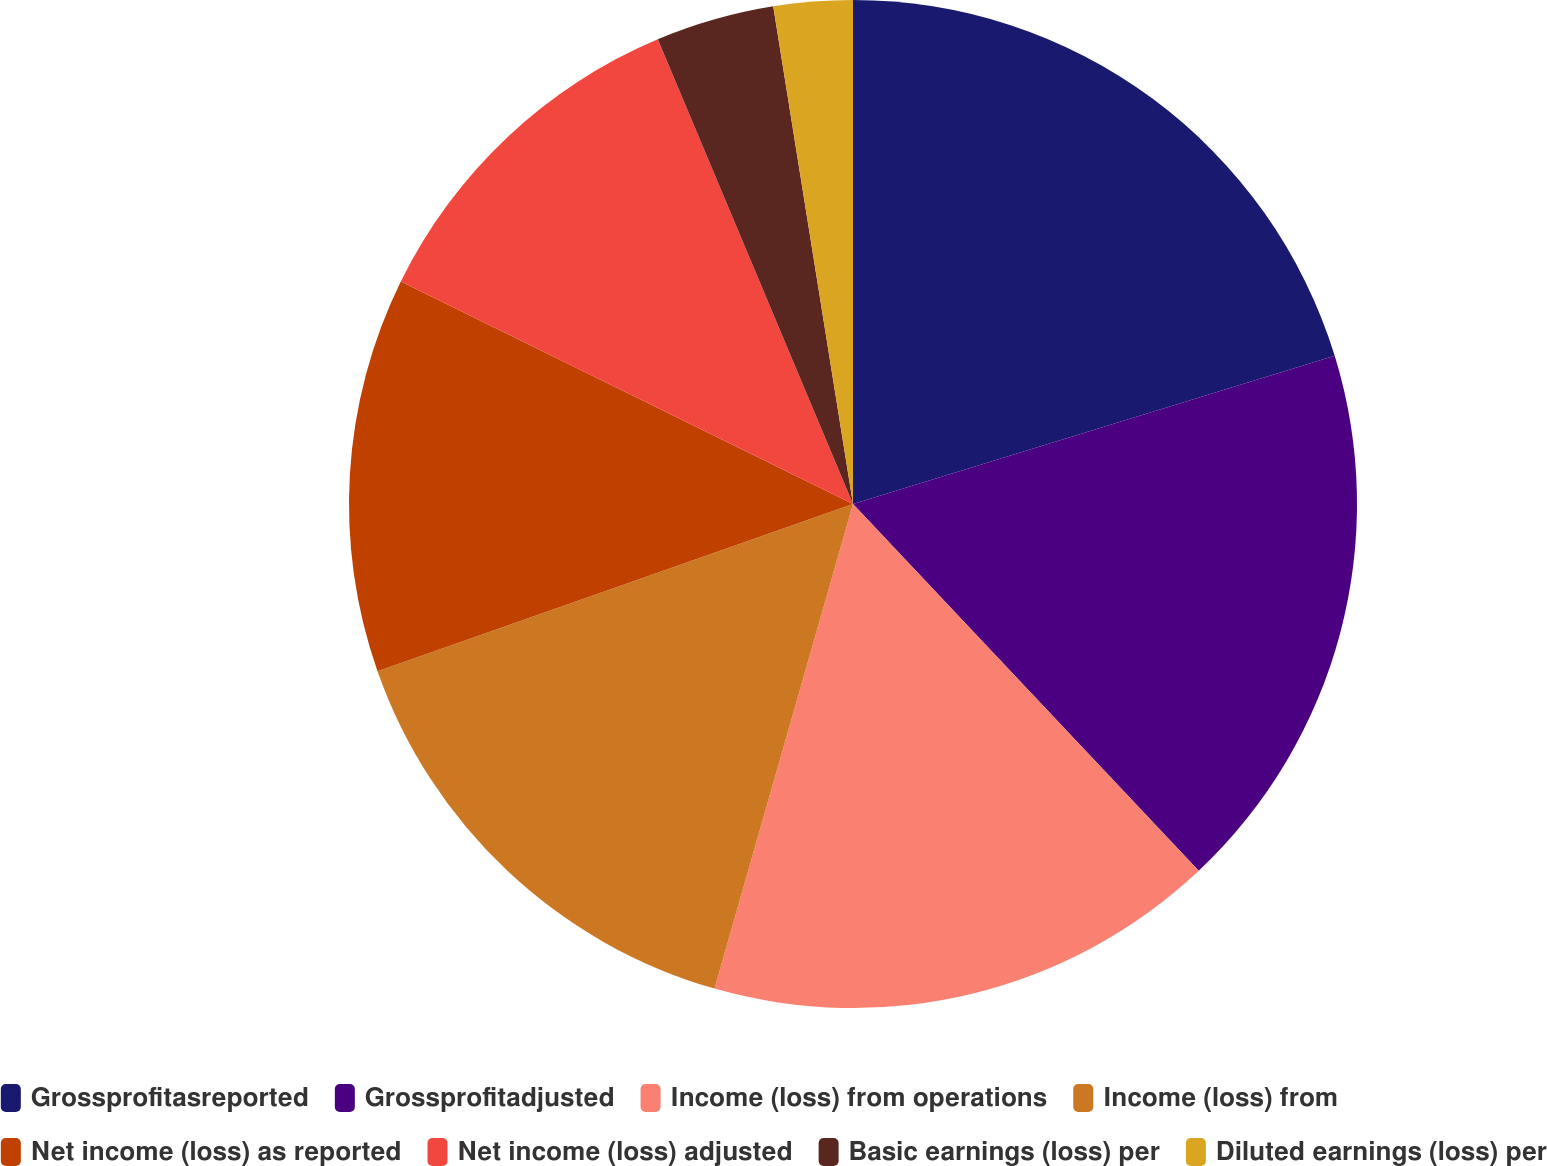<chart> <loc_0><loc_0><loc_500><loc_500><pie_chart><fcel>Grossprofitasreported<fcel>Grossprofitadjusted<fcel>Income (loss) from operations<fcel>Income (loss) from<fcel>Net income (loss) as reported<fcel>Net income (loss) adjusted<fcel>Basic earnings (loss) per<fcel>Diluted earnings (loss) per<nl><fcel>20.25%<fcel>17.72%<fcel>16.46%<fcel>15.19%<fcel>12.66%<fcel>11.39%<fcel>3.8%<fcel>2.53%<nl></chart> 